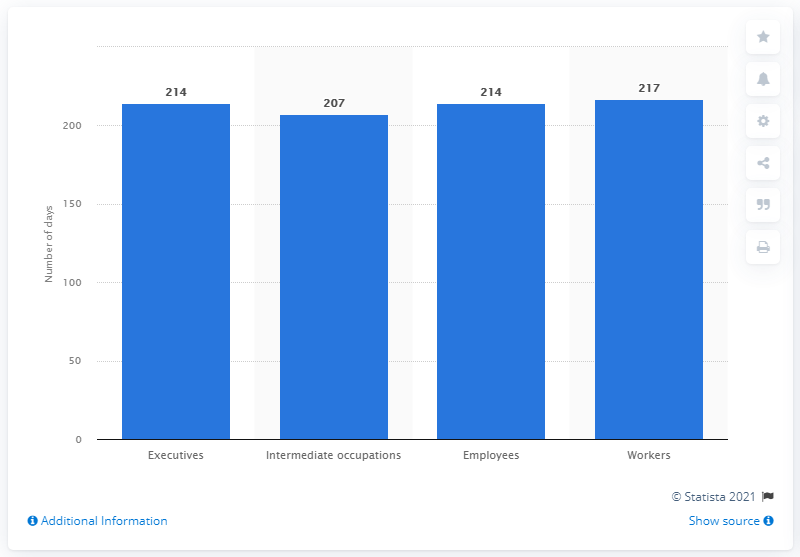Mention a couple of crucial points in this snapshot. In the year 207, intermediate professionals worked a total of 207 days. 